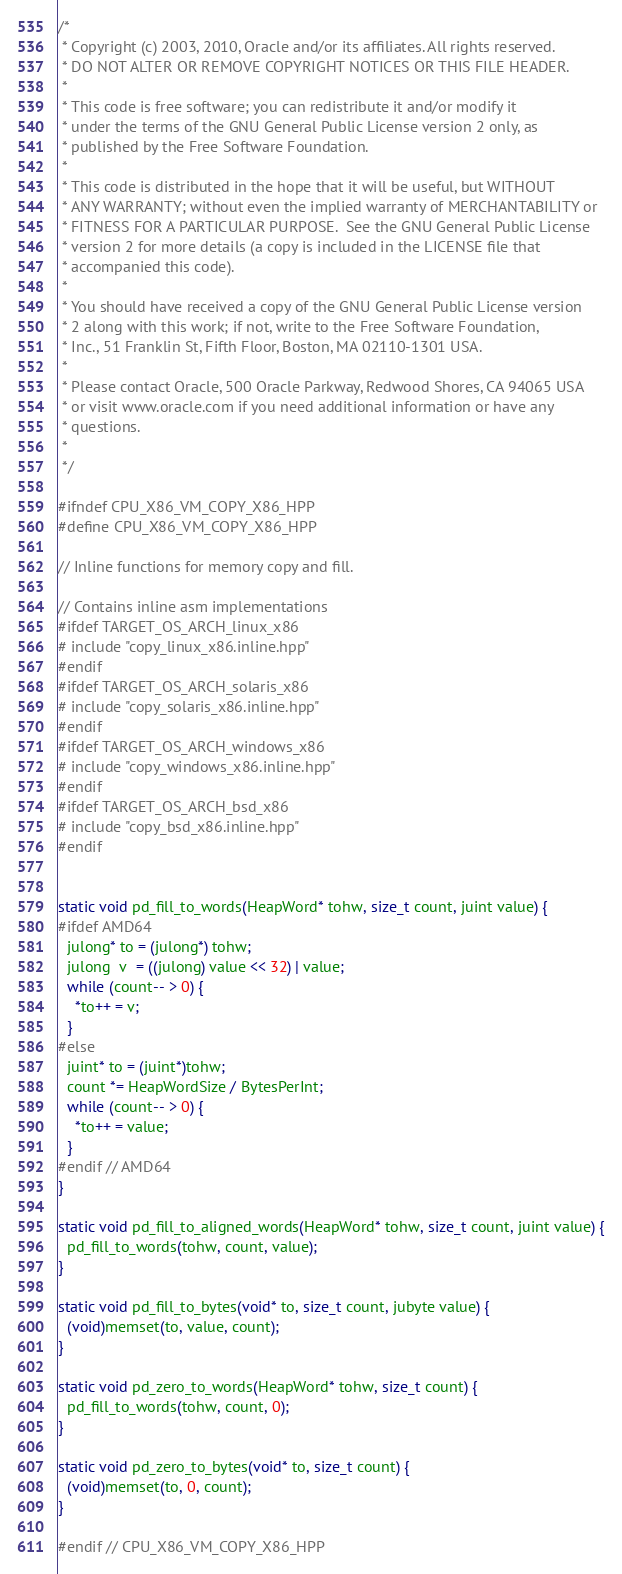Convert code to text. <code><loc_0><loc_0><loc_500><loc_500><_C++_>/*
 * Copyright (c) 2003, 2010, Oracle and/or its affiliates. All rights reserved.
 * DO NOT ALTER OR REMOVE COPYRIGHT NOTICES OR THIS FILE HEADER.
 *
 * This code is free software; you can redistribute it and/or modify it
 * under the terms of the GNU General Public License version 2 only, as
 * published by the Free Software Foundation.
 *
 * This code is distributed in the hope that it will be useful, but WITHOUT
 * ANY WARRANTY; without even the implied warranty of MERCHANTABILITY or
 * FITNESS FOR A PARTICULAR PURPOSE.  See the GNU General Public License
 * version 2 for more details (a copy is included in the LICENSE file that
 * accompanied this code).
 *
 * You should have received a copy of the GNU General Public License version
 * 2 along with this work; if not, write to the Free Software Foundation,
 * Inc., 51 Franklin St, Fifth Floor, Boston, MA 02110-1301 USA.
 *
 * Please contact Oracle, 500 Oracle Parkway, Redwood Shores, CA 94065 USA
 * or visit www.oracle.com if you need additional information or have any
 * questions.
 *
 */

#ifndef CPU_X86_VM_COPY_X86_HPP
#define CPU_X86_VM_COPY_X86_HPP

// Inline functions for memory copy and fill.

// Contains inline asm implementations
#ifdef TARGET_OS_ARCH_linux_x86
# include "copy_linux_x86.inline.hpp"
#endif
#ifdef TARGET_OS_ARCH_solaris_x86
# include "copy_solaris_x86.inline.hpp"
#endif
#ifdef TARGET_OS_ARCH_windows_x86
# include "copy_windows_x86.inline.hpp"
#endif
#ifdef TARGET_OS_ARCH_bsd_x86
# include "copy_bsd_x86.inline.hpp"
#endif


static void pd_fill_to_words(HeapWord* tohw, size_t count, juint value) {
#ifdef AMD64
  julong* to = (julong*) tohw;
  julong  v  = ((julong) value << 32) | value;
  while (count-- > 0) {
    *to++ = v;
  }
#else
  juint* to = (juint*)tohw;
  count *= HeapWordSize / BytesPerInt;
  while (count-- > 0) {
    *to++ = value;
  }
#endif // AMD64
}

static void pd_fill_to_aligned_words(HeapWord* tohw, size_t count, juint value) {
  pd_fill_to_words(tohw, count, value);
}

static void pd_fill_to_bytes(void* to, size_t count, jubyte value) {
  (void)memset(to, value, count);
}

static void pd_zero_to_words(HeapWord* tohw, size_t count) {
  pd_fill_to_words(tohw, count, 0);
}

static void pd_zero_to_bytes(void* to, size_t count) {
  (void)memset(to, 0, count);
}

#endif // CPU_X86_VM_COPY_X86_HPP
</code> 